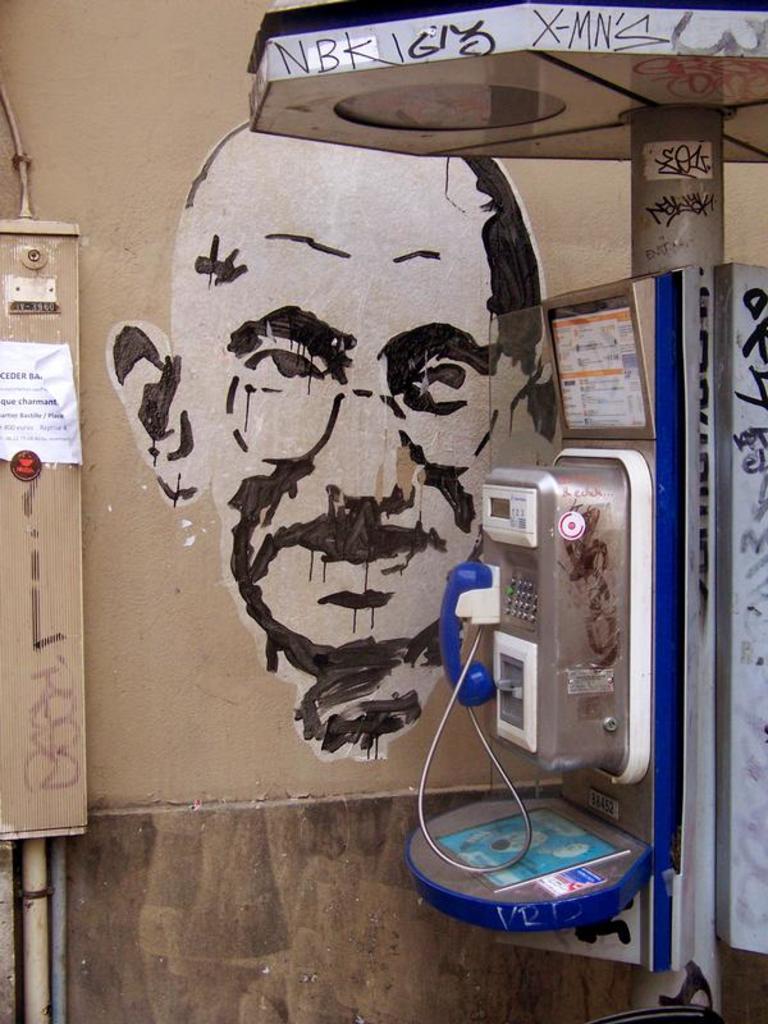Describe this image in one or two sentences. In this picture we can see a telephone, pole, pipe, poster, painting on the wall and some objects. 